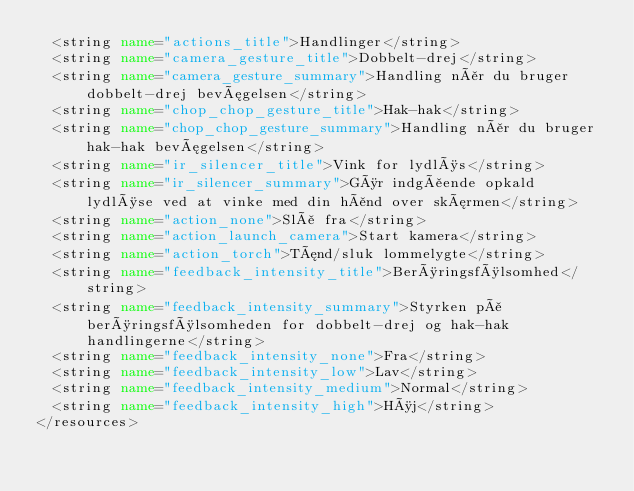<code> <loc_0><loc_0><loc_500><loc_500><_XML_>  <string name="actions_title">Handlinger</string>
  <string name="camera_gesture_title">Dobbelt-drej</string>
  <string name="camera_gesture_summary">Handling når du bruger dobbelt-drej bevægelsen</string>
  <string name="chop_chop_gesture_title">Hak-hak</string>
  <string name="chop_chop_gesture_summary">Handling når du bruger hak-hak bevægelsen</string>
  <string name="ir_silencer_title">Vink for lydløs</string>
  <string name="ir_silencer_summary">Gør indgående opkald lydløse ved at vinke med din hånd over skærmen</string>
  <string name="action_none">Slå fra</string>
  <string name="action_launch_camera">Start kamera</string>
  <string name="action_torch">Tænd/sluk lommelygte</string>
  <string name="feedback_intensity_title">Berøringsfølsomhed</string>
  <string name="feedback_intensity_summary">Styrken på berøringsfølsomheden for dobbelt-drej og hak-hak handlingerne</string>
  <string name="feedback_intensity_none">Fra</string>
  <string name="feedback_intensity_low">Lav</string>
  <string name="feedback_intensity_medium">Normal</string>
  <string name="feedback_intensity_high">Høj</string>
</resources>
</code> 